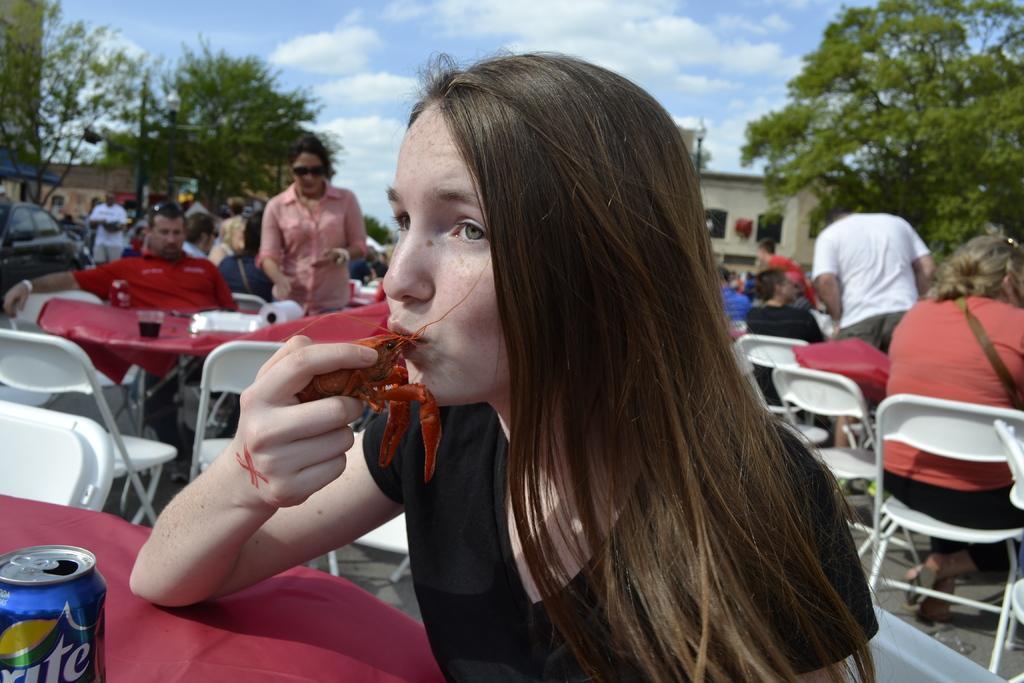Describe this image in one or two sentences. In the middle of the image few people are sitting and there are some tables, on the tables there are some glasses and bottles and tins. Behind them there are some vehicles and trees and buildings. At the top of the image there are some clouds in the sky. 